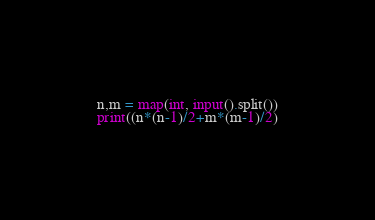<code> <loc_0><loc_0><loc_500><loc_500><_Python_>n,m = map(int, input().split())
print((n*(n-1)/2+m*(m-1)/2)</code> 